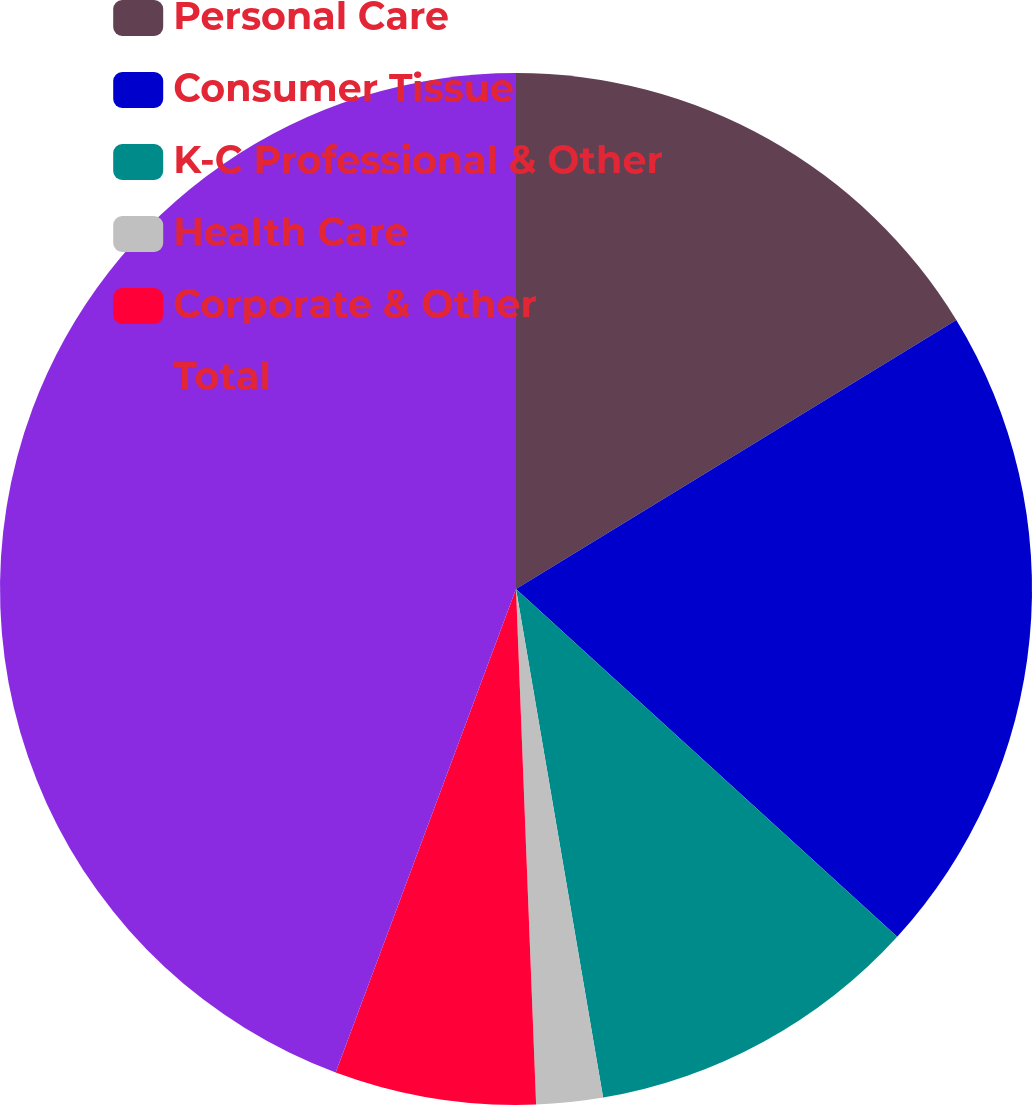Convert chart to OTSL. <chart><loc_0><loc_0><loc_500><loc_500><pie_chart><fcel>Personal Care<fcel>Consumer Tissue<fcel>K-C Professional & Other<fcel>Health Care<fcel>Corporate & Other<fcel>Total<nl><fcel>16.27%<fcel>20.5%<fcel>10.53%<fcel>2.08%<fcel>6.3%<fcel>44.32%<nl></chart> 